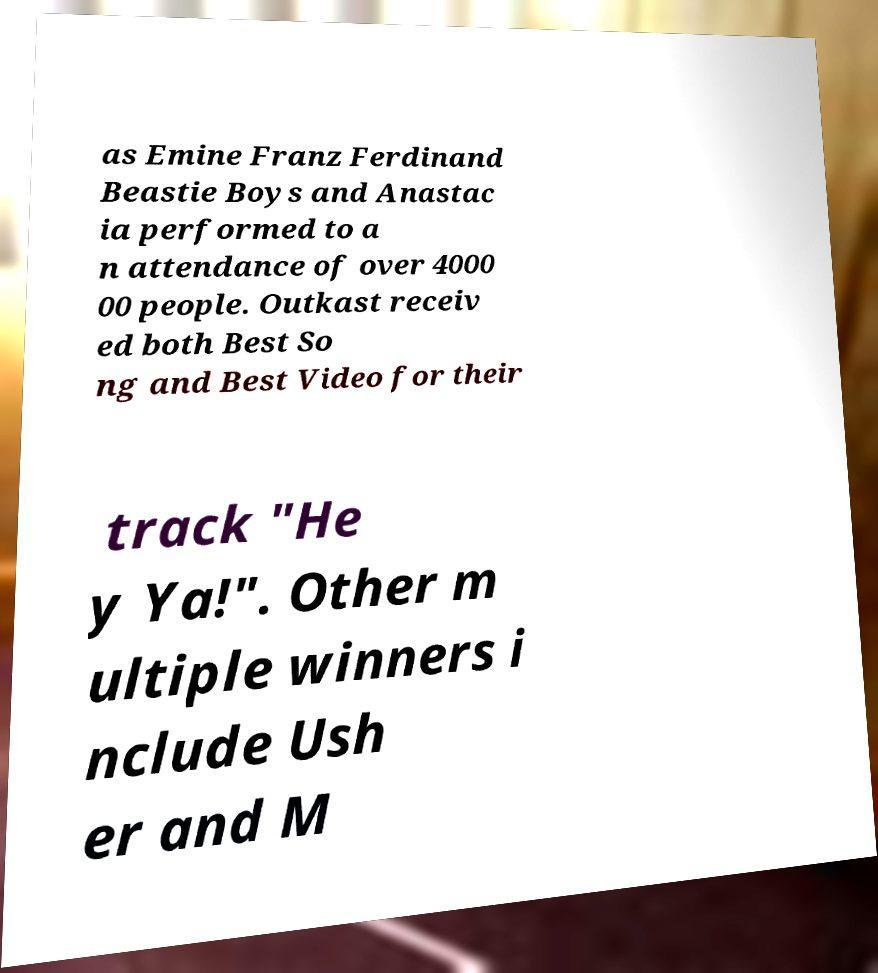Could you assist in decoding the text presented in this image and type it out clearly? as Emine Franz Ferdinand Beastie Boys and Anastac ia performed to a n attendance of over 4000 00 people. Outkast receiv ed both Best So ng and Best Video for their track "He y Ya!". Other m ultiple winners i nclude Ush er and M 